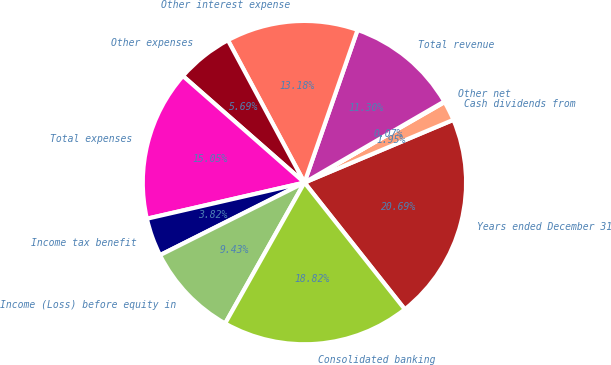<chart> <loc_0><loc_0><loc_500><loc_500><pie_chart><fcel>Years ended December 31<fcel>Cash dividends from<fcel>Other net<fcel>Total revenue<fcel>Other interest expense<fcel>Other expenses<fcel>Total expenses<fcel>Income tax benefit<fcel>Income (Loss) before equity in<fcel>Consolidated banking<nl><fcel>20.69%<fcel>1.95%<fcel>0.07%<fcel>11.3%<fcel>13.18%<fcel>5.69%<fcel>15.05%<fcel>3.82%<fcel>9.43%<fcel>18.82%<nl></chart> 